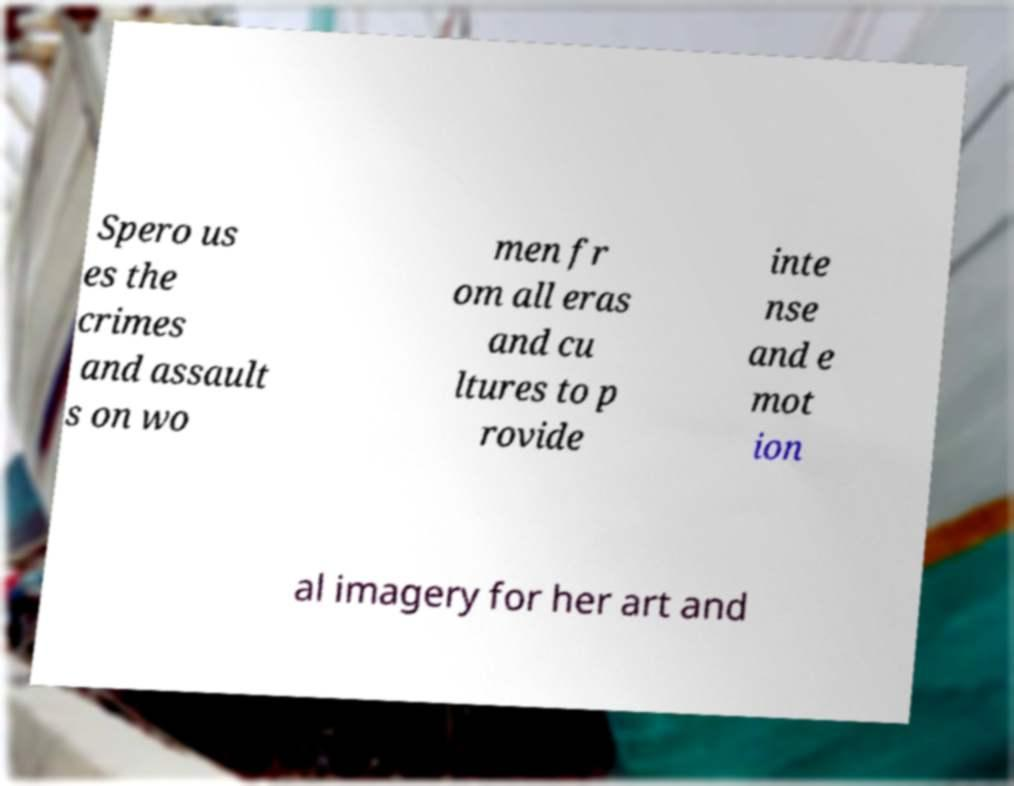What messages or text are displayed in this image? I need them in a readable, typed format. Spero us es the crimes and assault s on wo men fr om all eras and cu ltures to p rovide inte nse and e mot ion al imagery for her art and 